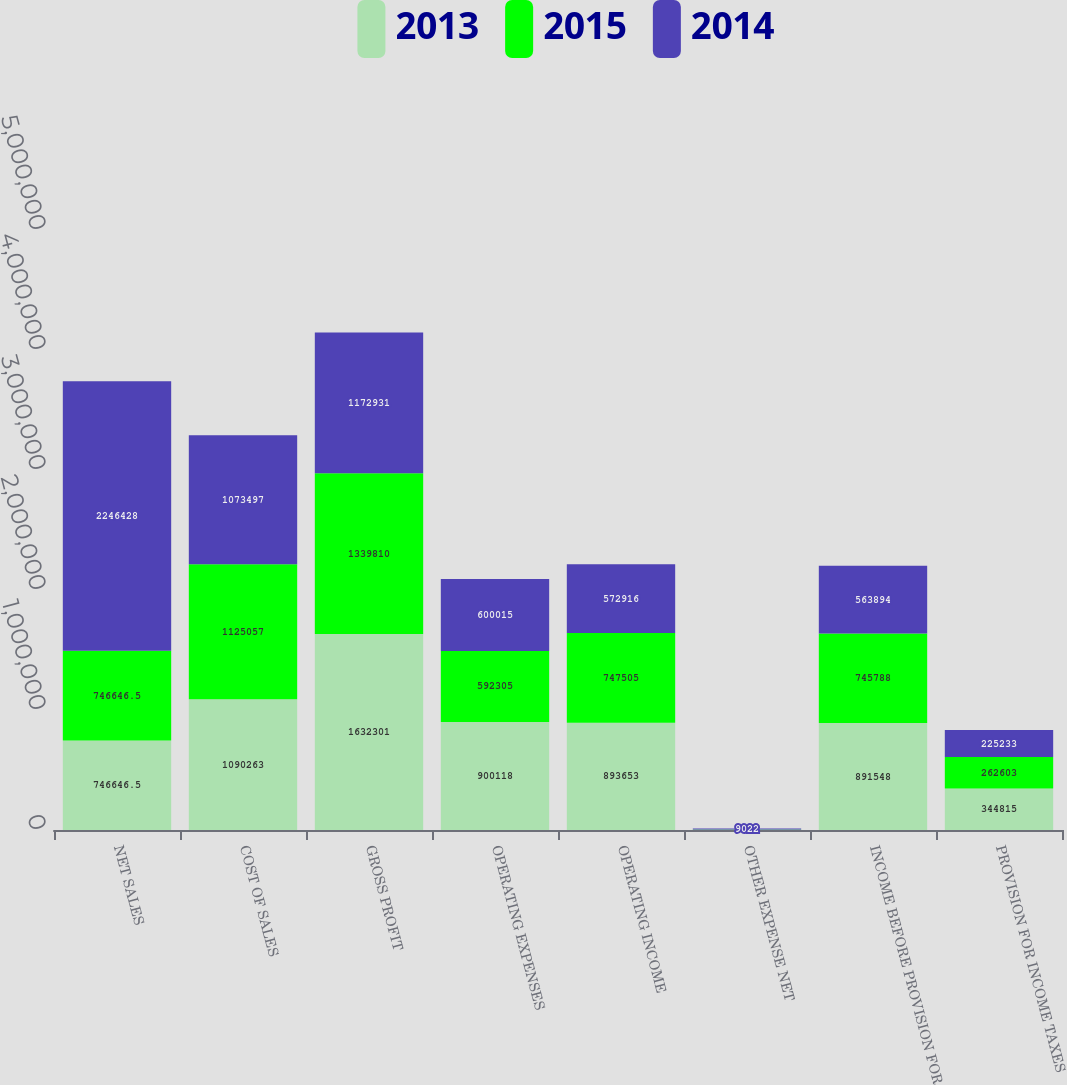Convert chart. <chart><loc_0><loc_0><loc_500><loc_500><stacked_bar_chart><ecel><fcel>NET SALES<fcel>COST OF SALES<fcel>GROSS PROFIT<fcel>OPERATING EXPENSES<fcel>OPERATING INCOME<fcel>OTHER EXPENSE NET<fcel>INCOME BEFORE PROVISION FOR<fcel>PROVISION FOR INCOME TAXES<nl><fcel>2013<fcel>746646<fcel>1.09026e+06<fcel>1.6323e+06<fcel>900118<fcel>893653<fcel>2105<fcel>891548<fcel>344815<nl><fcel>2015<fcel>746646<fcel>1.12506e+06<fcel>1.33981e+06<fcel>592305<fcel>747505<fcel>1717<fcel>745788<fcel>262603<nl><fcel>2014<fcel>2.24643e+06<fcel>1.0735e+06<fcel>1.17293e+06<fcel>600015<fcel>572916<fcel>9022<fcel>563894<fcel>225233<nl></chart> 